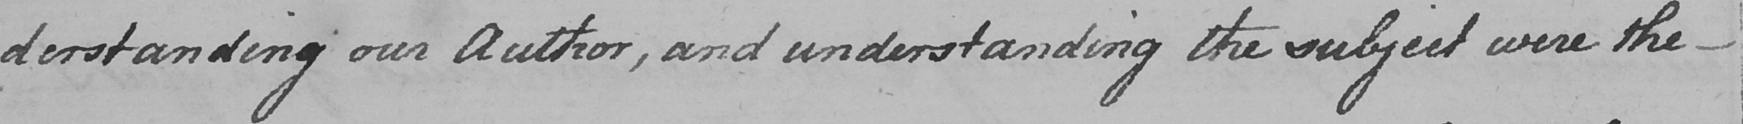Can you tell me what this handwritten text says? derstanding our Author , and understanding the subject were the  _ 